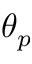<formula> <loc_0><loc_0><loc_500><loc_500>\theta _ { p }</formula> 